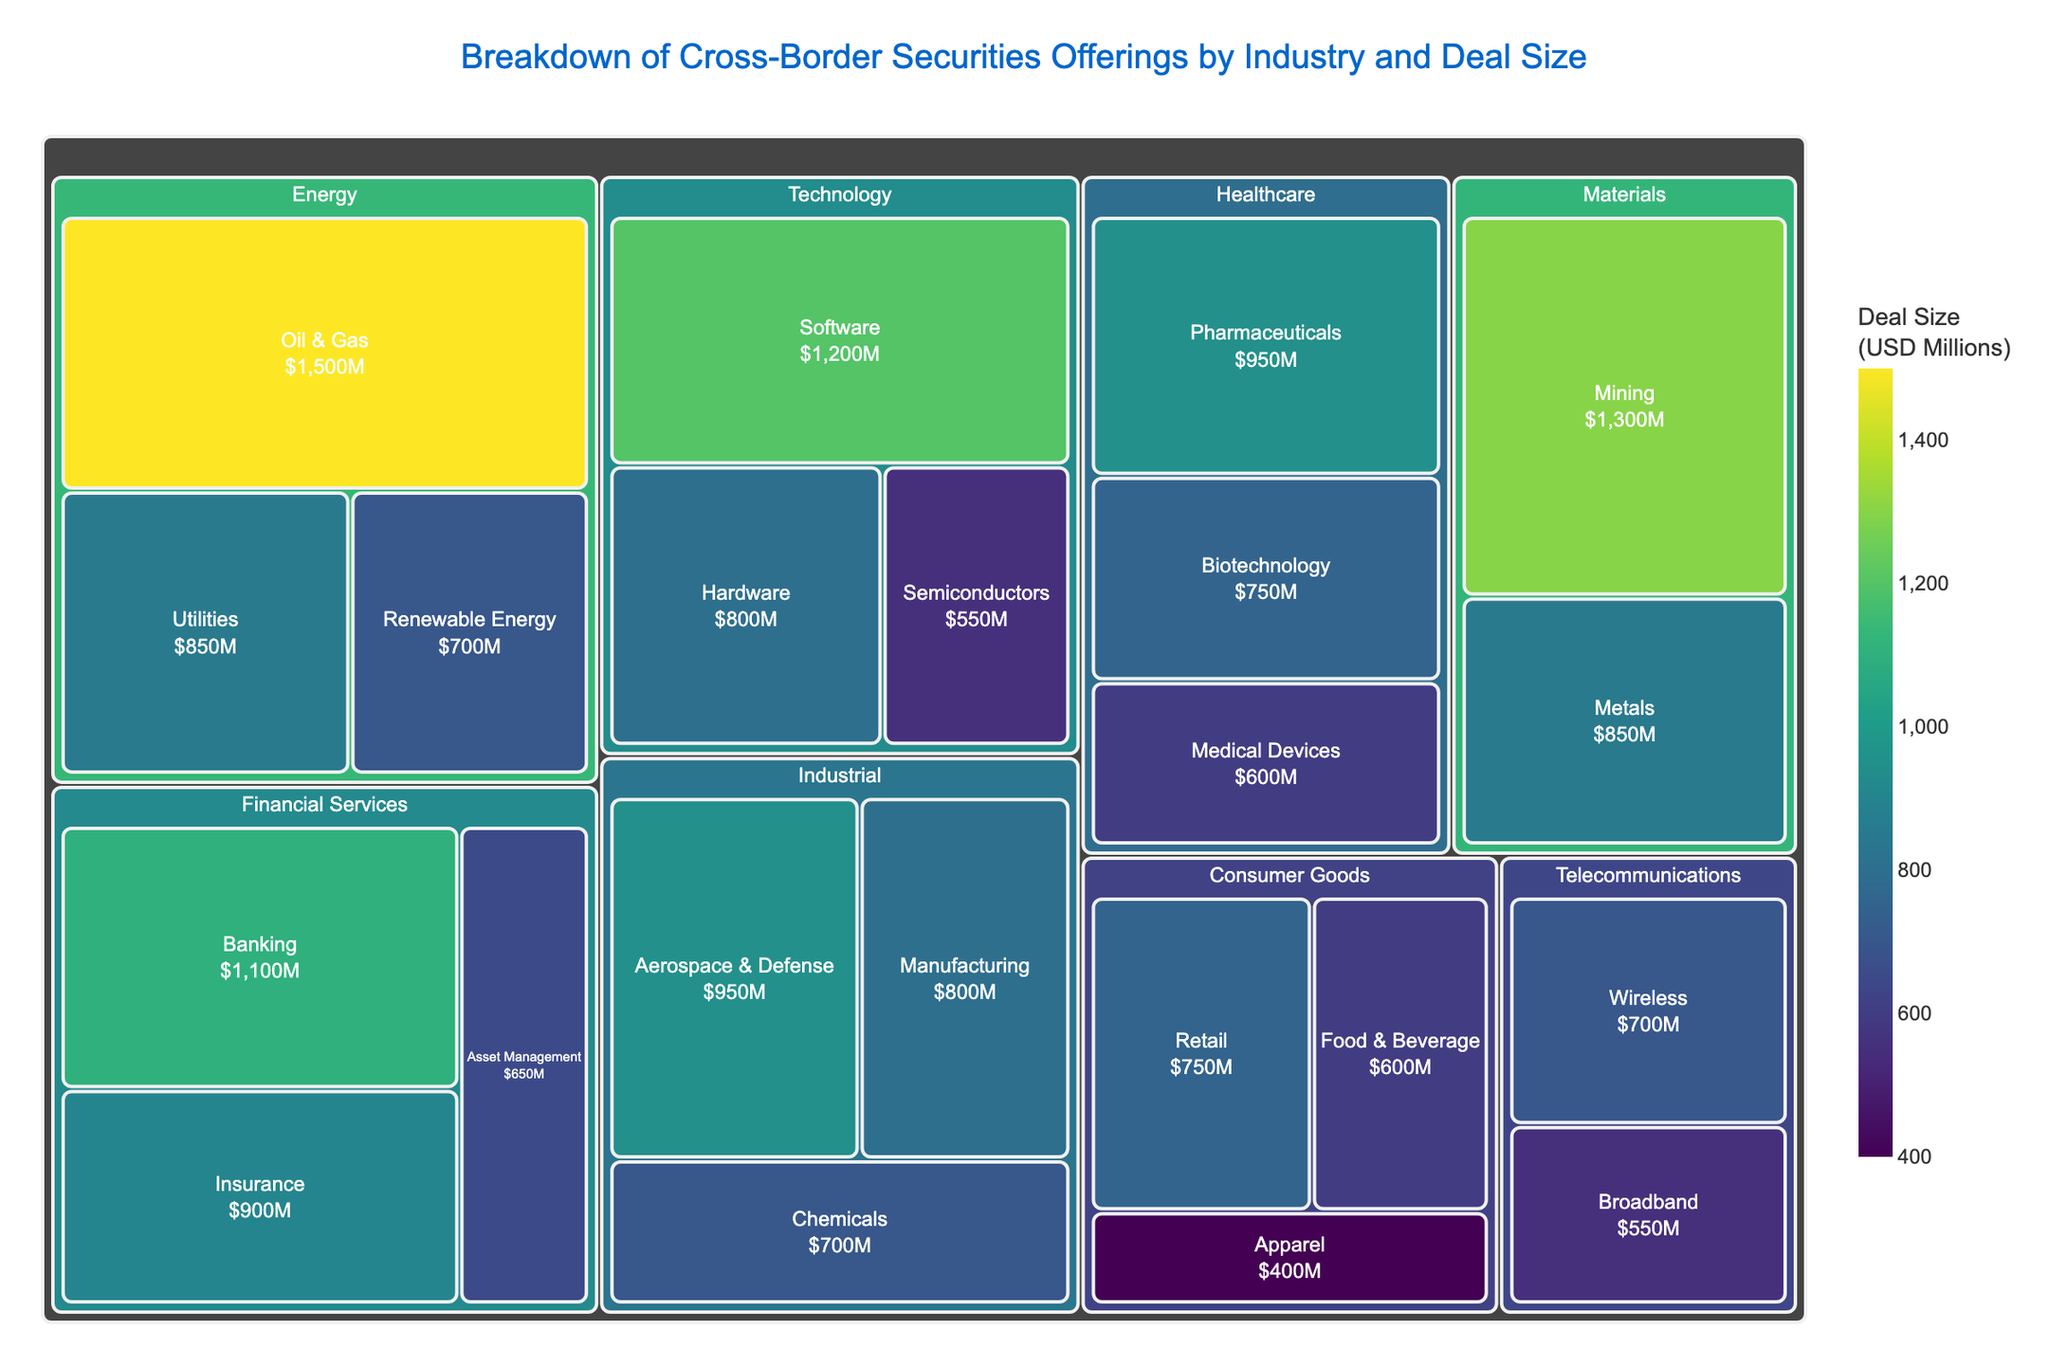What is the title of the treemap? The title of the treemap is usually located at the top center of the figure.
Answer: Breakdown of Cross-Border Securities Offerings by Industry and Deal Size Which industry has the largest deal size? By observing the size of the blocks in the treemap, the largest block corresponds to the industry with the highest deal size.
Answer: Energy What is the deal size for the Software sector in the Technology industry? Locate the Technology industry block and identify the Software sector within it. The deal size is indicated within the block.
Answer: $1,200M How many industries are represented in the treemap? Count the number of main blocks, each representing a different industry.
Answer: 7 Which sector within the Healthcare industry has the smallest deal size? Within the Healthcare industry block, compare the sizes of the sectors and identify the one with the smallest block.
Answer: Medical Devices What is the total deal size for the Financial Services industry? Sum the deal sizes of all sectors within the Financial Services industry. $1,100M (Banking) + $900M (Insurance) + $650M (Asset Management)
Answer: $2,650M Is the deal size for the Mining sector in the Materials industry greater than that of the Pharmaceuticals sector in the Healthcare industry? Compare the deal sizes of the Mining ($1,300M) and Pharmaceuticals ($950M) sectors.
Answer: Yes What is the average deal size of the sectors within the Consumer Goods industry? Calculate the average by summing the deal sizes and dividing by the number of sectors in the Consumer Goods industry. ($750M + $600M + $400M) / 3
Answer: $583.33M Which two sectors in the Telecommunications industry have deal sizes, and what are they? Identify the sectors within Telecommunications and note their deal sizes. Wireless ($700M) and Broadband ($550M)
Answer: Wireless ($700M), Broadband ($550M) What is the difference in deal size between the largest and smallest sectors in the Industrial industry? Subtract the smallest deal size in the Industrial industry (Chemicals, $700M) from the largest (Aerospace & Defense, $950M).
Answer: $250M 